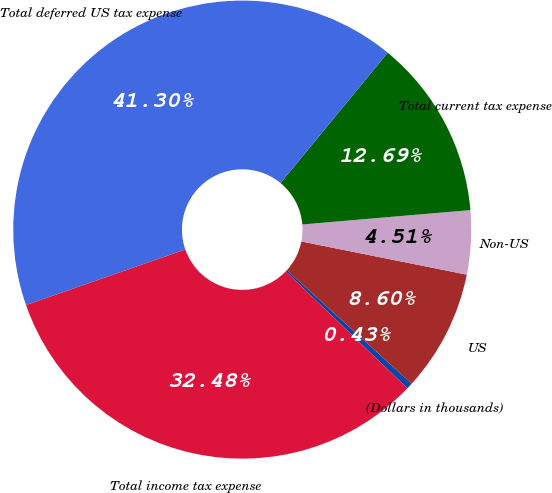<chart> <loc_0><loc_0><loc_500><loc_500><pie_chart><fcel>(Dollars in thousands)<fcel>US<fcel>Non-US<fcel>Total current tax expense<fcel>Total deferred US tax expense<fcel>Total income tax expense<nl><fcel>0.43%<fcel>8.6%<fcel>4.51%<fcel>12.69%<fcel>41.3%<fcel>32.48%<nl></chart> 